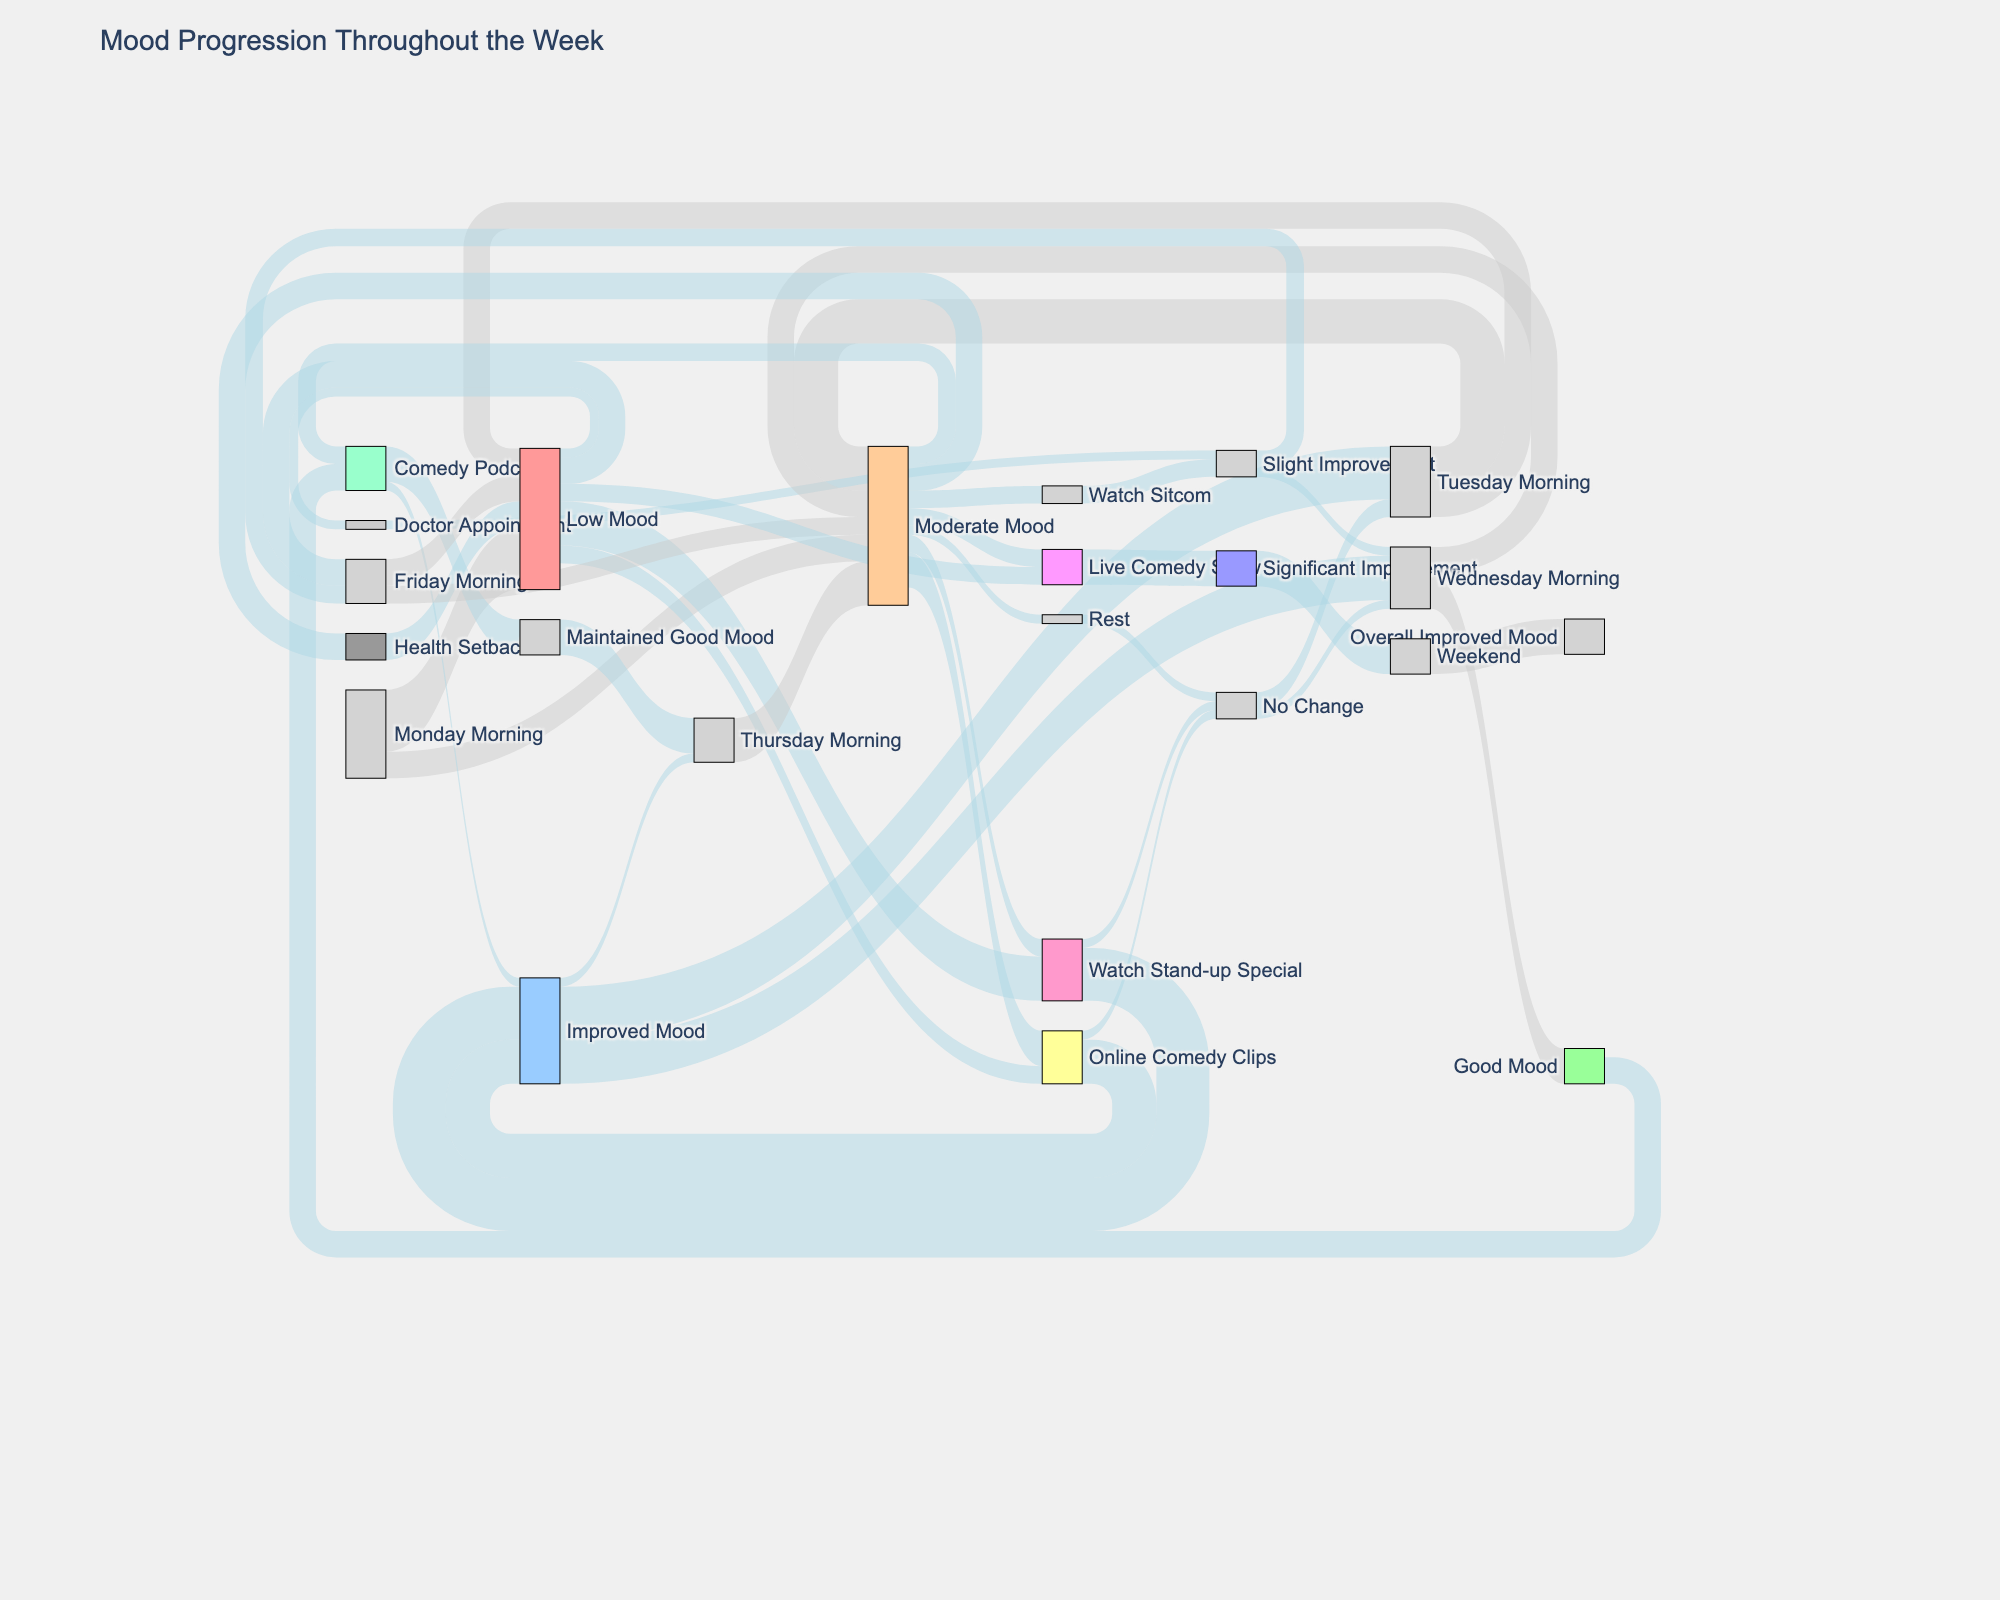what is the title of the Sankey diagram? The title of the Sankey diagram can be found at the top of the figure. In this case, it reads "Mood Progression Throughout the Week".
Answer: Mood Progression Throughout the Week What is the initial mood state on Monday morning? Check the node labels linked from "Monday Morning" to find the initial mood states. "Monday Morning" transitions to "Low Mood" and "Moderate Mood".
Answer: Low Mood, Moderate Mood What activity results in the largest mood improvement throughout the week? Look for the activity nodes and see which one leads to "Significant Improvement". The "Live Comedy Show" leads to "Significant Improvement" which transitions to the overall "Improved Mood" over the weekend.
Answer: Live Comedy Show Which mood state on Wednesday is the most common? Check the nodes linked from "Wednesday Morning" to see which mood state has the highest connection value. "Good Mood" from "Wednesday Morning" has a value of 40 which is the highest.
Answer: Good Mood How does watching a comedy podcast affect the mood? Check the node labeled "Comedy Podcast". It leads responses to "Maintained Good Mood" with 40 value and "Improved Mood" with 10 value.
Answer: Maintained Good Mood, Improved Mood How many units of mood improvement come from watching stand-up specials by Tuesday morning? Track the units from "Watch Stand-up Special" to "Improved Mood", which then transitions to "Tuesday Morning". The value is 60 units.
Answer: 60 units Compare the effects of "Live Comedy Show" and "Doctor Appointment" on mood state. Which is more effective in improvement? Look at the values leading from these activities. "Live Comedy Show" leads to "Significant Improvement" with a value of 40, while "Doctor Appointment" leads to "Slight Improvement" with a value of 10. Therefore, "Live Comedy Show" is more effective.
Answer: Live Comedy Show Does any comedy consumption occur on Thursday? If so, which? Look for any nodes on Thursday related to comedy consumption. "Thursday Morning" transitions to "Watch Sitcom" with a value of 20.
Answer: Watch Sitcom How many times does mood transition to "Moderate Mood" throughout the week? Count the number of nodes labeled "Moderate Mood". There are three transitions from "Monday Morning", "Tuesday Morning", and "Thursday Morning".
Answer: Three transitions What is the final mood state by the weekend? Trace the progression towards the end of the timeline on the diagram. The final state by the weekend shows "Overall Improved Mood" with a value of 40.
Answer: Overall Improved Mood 